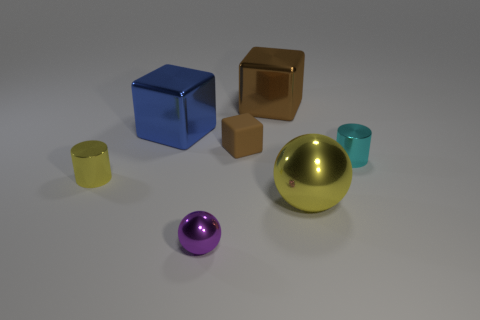Does the big blue block have the same material as the tiny cylinder left of the tiny cyan cylinder?
Give a very brief answer. Yes. Is the number of brown objects greater than the number of big gray shiny balls?
Ensure brevity in your answer.  Yes. What number of blocks are either matte things or large brown objects?
Offer a terse response. 2. The rubber cube is what color?
Ensure brevity in your answer.  Brown. There is a cylinder that is left of the cyan thing; is its size the same as the metal ball that is to the left of the small brown object?
Provide a short and direct response. Yes. Is the number of large yellow shiny things less than the number of big cyan matte blocks?
Provide a short and direct response. No. There is a small cube; what number of blocks are on the right side of it?
Your response must be concise. 1. What is the blue block made of?
Your response must be concise. Metal. Is the large sphere the same color as the small rubber object?
Provide a succinct answer. No. Are there fewer cyan shiny cylinders that are right of the purple metal sphere than tiny blue spheres?
Your response must be concise. No. 